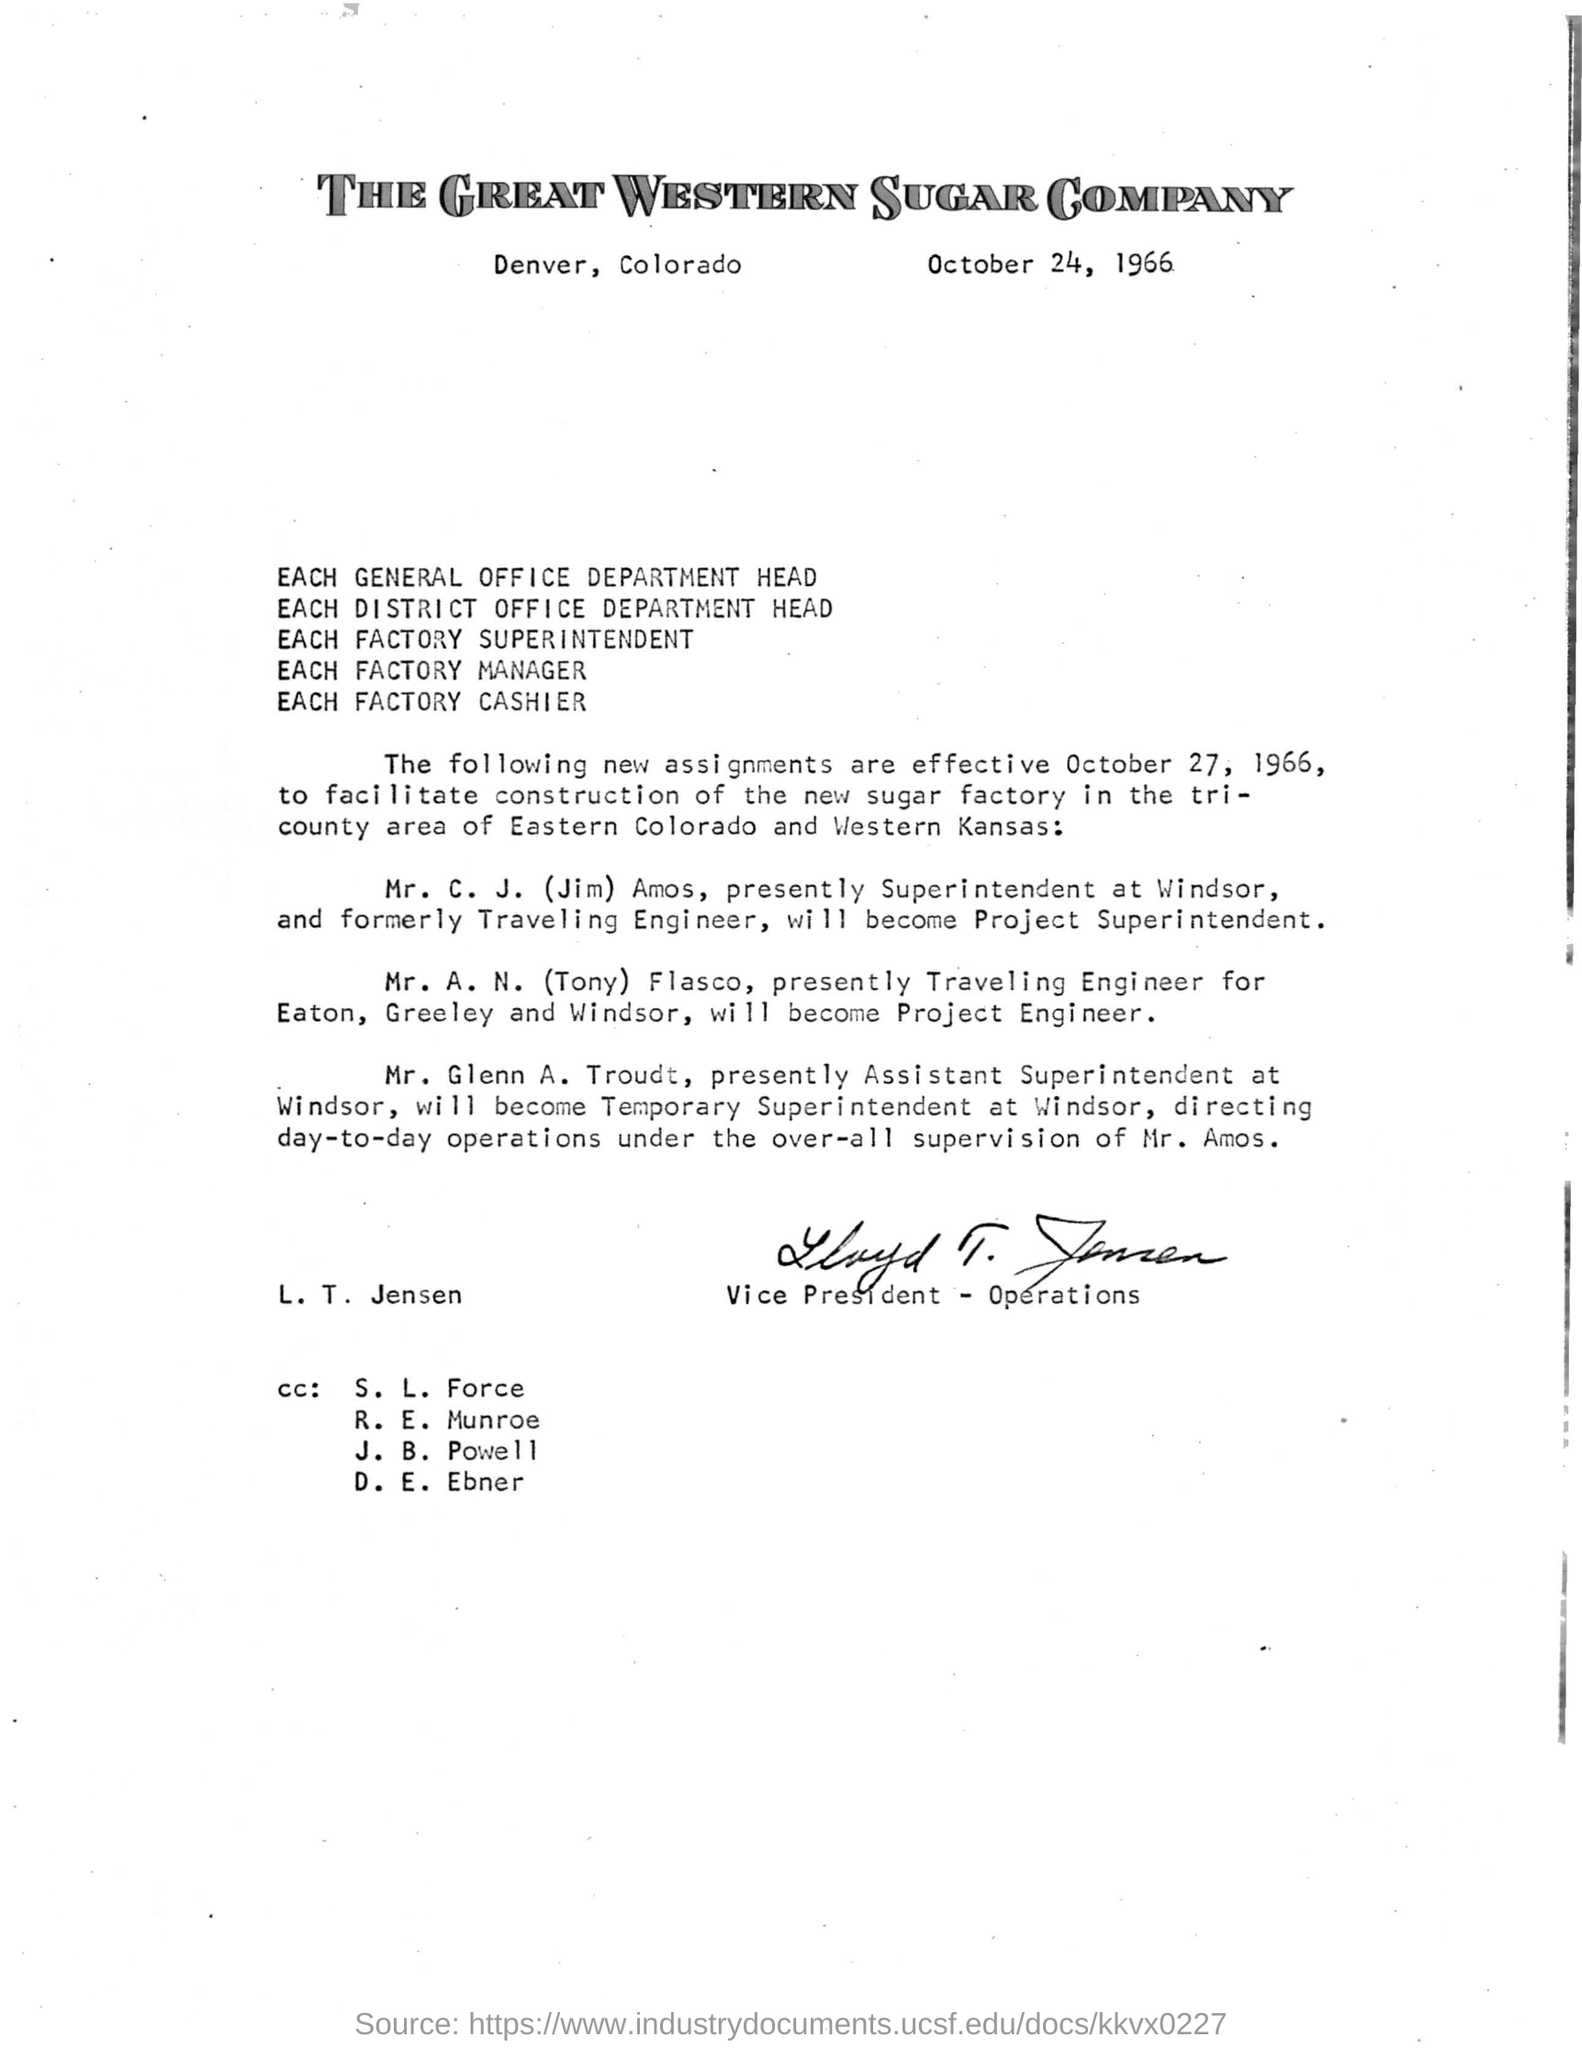Who has signed the letter?
Offer a very short reply. L. T. Jensen. What is the issued date of the letter?
Keep it short and to the point. October 24, 1966. 